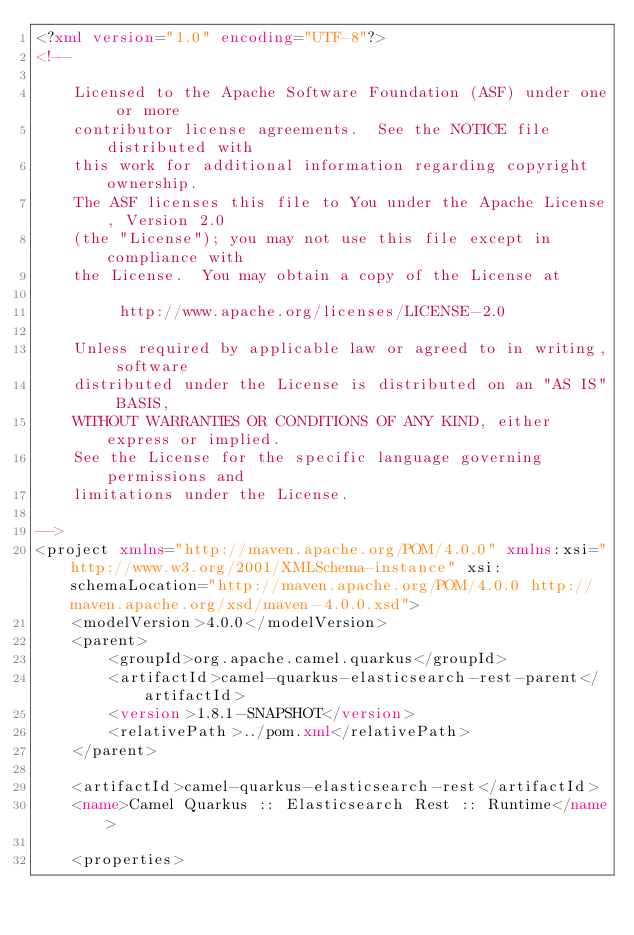<code> <loc_0><loc_0><loc_500><loc_500><_XML_><?xml version="1.0" encoding="UTF-8"?>
<!--

    Licensed to the Apache Software Foundation (ASF) under one or more
    contributor license agreements.  See the NOTICE file distributed with
    this work for additional information regarding copyright ownership.
    The ASF licenses this file to You under the Apache License, Version 2.0
    (the "License"); you may not use this file except in compliance with
    the License.  You may obtain a copy of the License at

         http://www.apache.org/licenses/LICENSE-2.0

    Unless required by applicable law or agreed to in writing, software
    distributed under the License is distributed on an "AS IS" BASIS,
    WITHOUT WARRANTIES OR CONDITIONS OF ANY KIND, either express or implied.
    See the License for the specific language governing permissions and
    limitations under the License.

-->
<project xmlns="http://maven.apache.org/POM/4.0.0" xmlns:xsi="http://www.w3.org/2001/XMLSchema-instance" xsi:schemaLocation="http://maven.apache.org/POM/4.0.0 http://maven.apache.org/xsd/maven-4.0.0.xsd">
    <modelVersion>4.0.0</modelVersion>
    <parent>
        <groupId>org.apache.camel.quarkus</groupId>
        <artifactId>camel-quarkus-elasticsearch-rest-parent</artifactId>
        <version>1.8.1-SNAPSHOT</version>
        <relativePath>../pom.xml</relativePath>
    </parent>

    <artifactId>camel-quarkus-elasticsearch-rest</artifactId>
    <name>Camel Quarkus :: Elasticsearch Rest :: Runtime</name>

    <properties></code> 